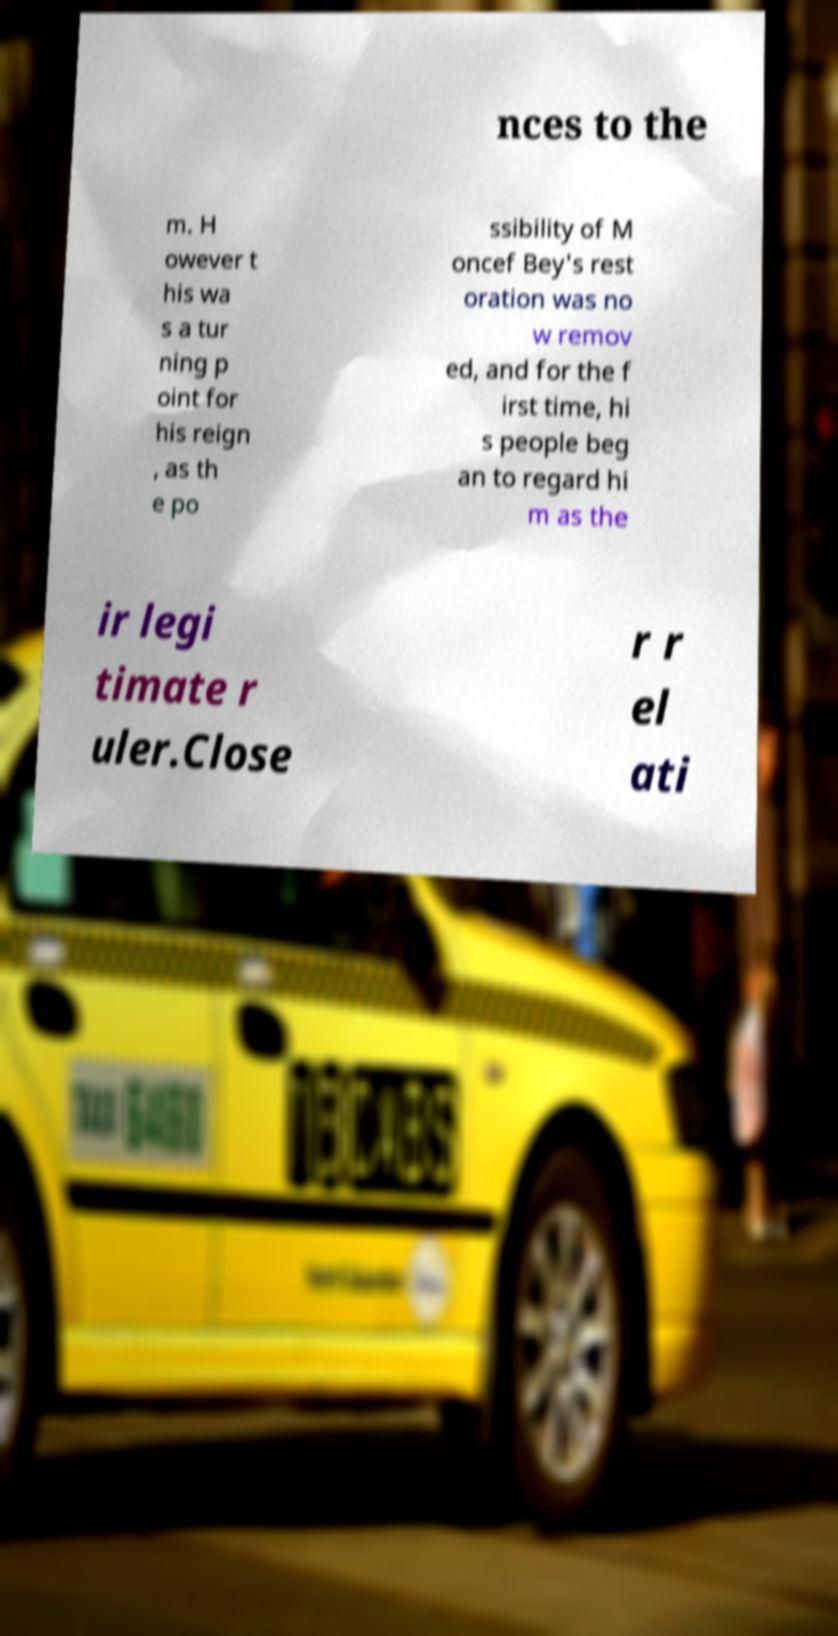Can you accurately transcribe the text from the provided image for me? nces to the m. H owever t his wa s a tur ning p oint for his reign , as th e po ssibility of M oncef Bey's rest oration was no w remov ed, and for the f irst time, hi s people beg an to regard hi m as the ir legi timate r uler.Close r r el ati 